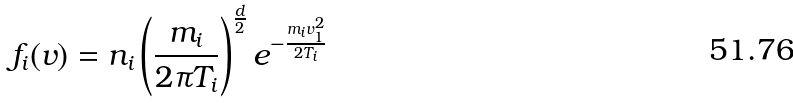Convert formula to latex. <formula><loc_0><loc_0><loc_500><loc_500>f _ { i } ( v ) = n _ { i } \left ( \frac { m _ { i } } { 2 \pi T _ { i } } \right ) ^ { \frac { d } { 2 } } e ^ { - \frac { m _ { i } v _ { 1 } ^ { 2 } } { 2 T _ { i } } }</formula> 